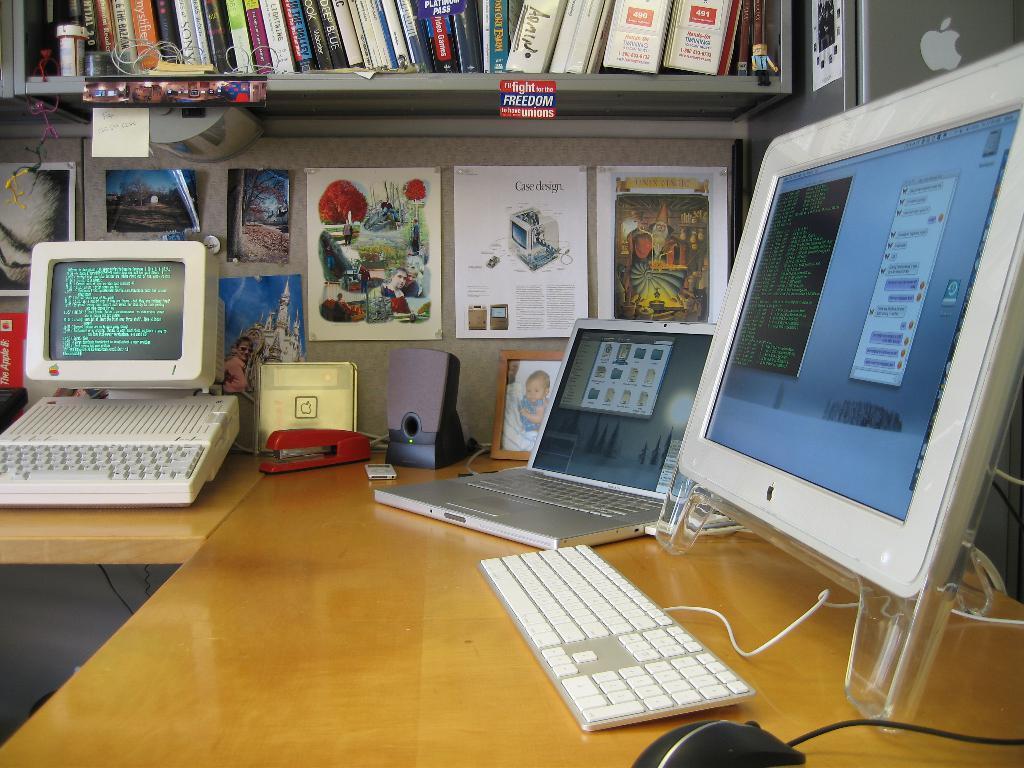In one or two sentences, can you explain what this image depicts? Inn the picture there is a rack full of books. On the table there monitor, laptop and few other things. on the wall there are paintings. 